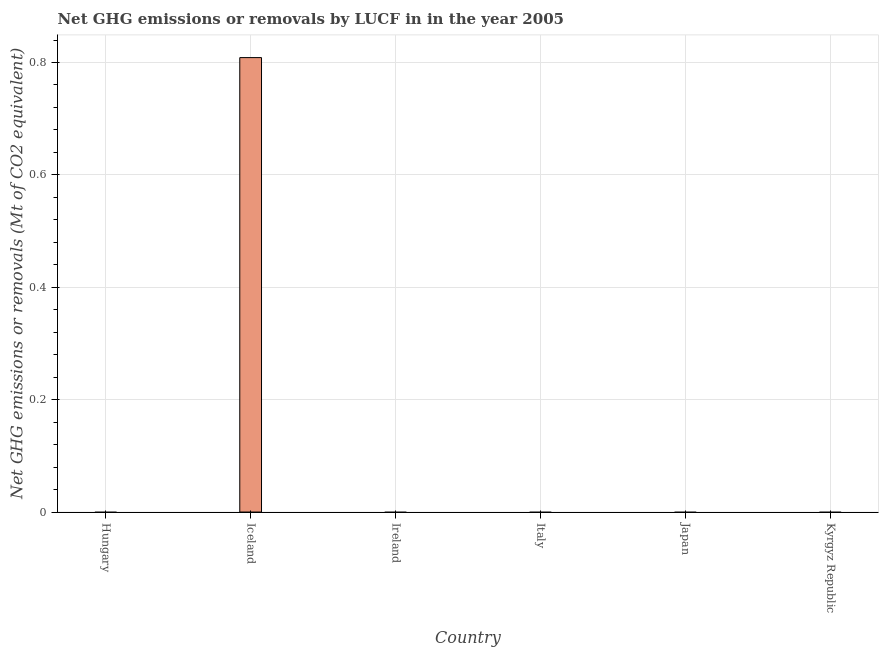Does the graph contain any zero values?
Provide a short and direct response. Yes. Does the graph contain grids?
Your response must be concise. Yes. What is the title of the graph?
Keep it short and to the point. Net GHG emissions or removals by LUCF in in the year 2005. What is the label or title of the Y-axis?
Provide a succinct answer. Net GHG emissions or removals (Mt of CO2 equivalent). What is the ghg net emissions or removals in Iceland?
Give a very brief answer. 0.81. Across all countries, what is the maximum ghg net emissions or removals?
Give a very brief answer. 0.81. What is the sum of the ghg net emissions or removals?
Your answer should be very brief. 0.81. What is the average ghg net emissions or removals per country?
Provide a short and direct response. 0.14. What is the median ghg net emissions or removals?
Your response must be concise. 0. What is the difference between the highest and the lowest ghg net emissions or removals?
Your answer should be compact. 0.81. How many bars are there?
Give a very brief answer. 1. How many countries are there in the graph?
Your answer should be compact. 6. Are the values on the major ticks of Y-axis written in scientific E-notation?
Give a very brief answer. No. What is the Net GHG emissions or removals (Mt of CO2 equivalent) in Hungary?
Provide a succinct answer. 0. What is the Net GHG emissions or removals (Mt of CO2 equivalent) in Iceland?
Provide a succinct answer. 0.81. What is the Net GHG emissions or removals (Mt of CO2 equivalent) in Italy?
Provide a succinct answer. 0. What is the Net GHG emissions or removals (Mt of CO2 equivalent) of Kyrgyz Republic?
Provide a short and direct response. 0. 